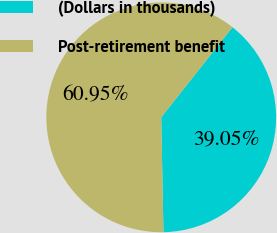<chart> <loc_0><loc_0><loc_500><loc_500><pie_chart><fcel>(Dollars in thousands)<fcel>Post-retirement benefit<nl><fcel>39.05%<fcel>60.95%<nl></chart> 